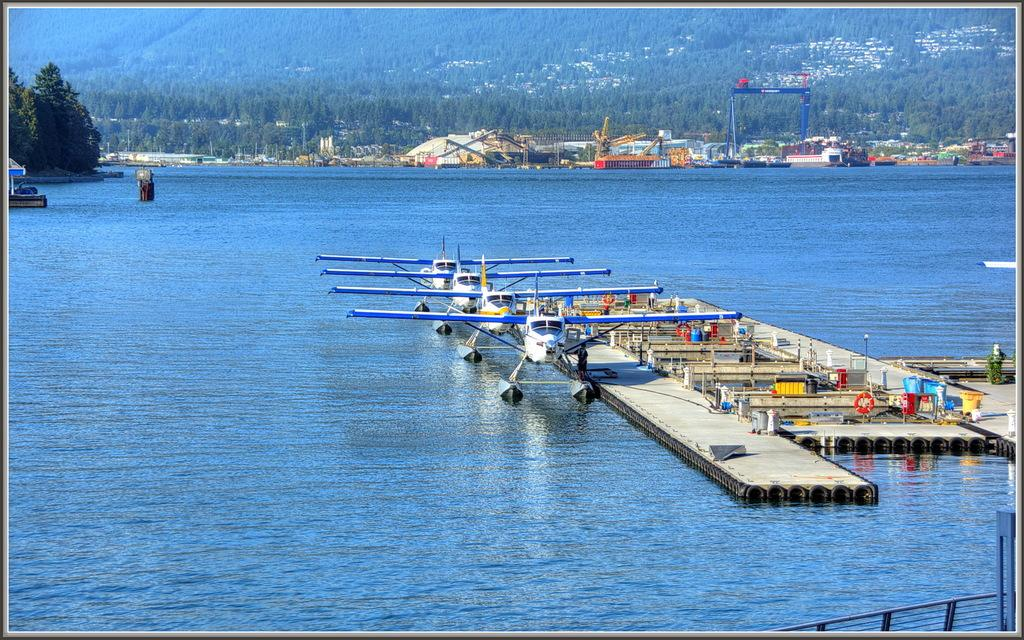Where was the image taken? The image was clicked outside. What can be seen floating on the water in the image? There are airplanes on water in the image. What type of vegetation is visible at the top of the image? There are trees at the top of the image. What type of structures are visible at the top of the image? There are buildings at the top of the image. What is present in the middle of the image? There is water in the middle of the image. What type of canvas is used to create the watch in the image? There is no watch present in the image, so it is not possible to determine the type of canvas used. 